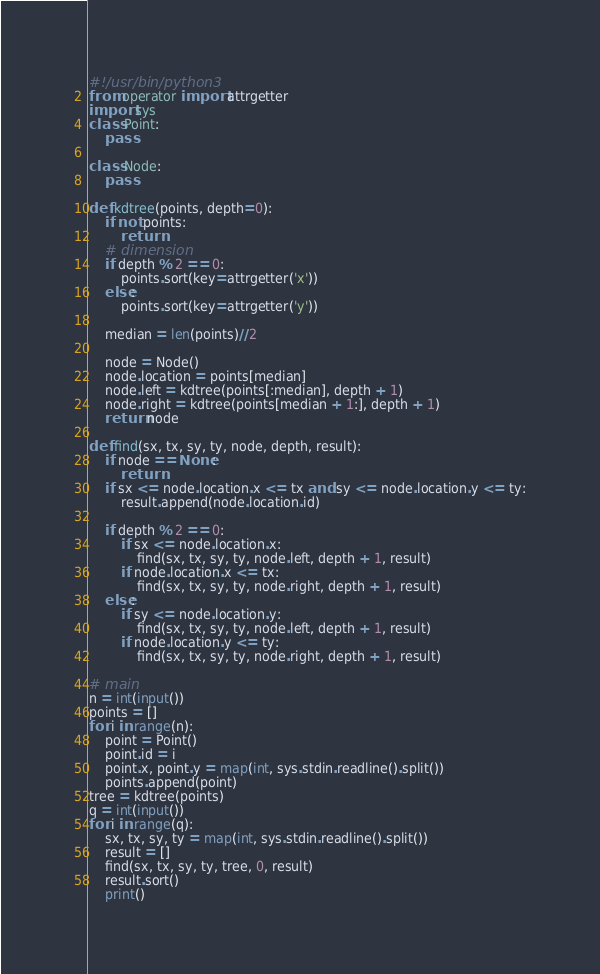<code> <loc_0><loc_0><loc_500><loc_500><_Python_>#!/usr/bin/python3
from operator import attrgetter
import sys
class Point:
    pass

class Node:
    pass

def kdtree(points, depth=0):
    if not points:
        return
    # dimension
    if depth % 2 == 0:
        points.sort(key=attrgetter('x'))
    else:
        points.sort(key=attrgetter('y'))

    median = len(points)//2

    node = Node()
    node.location = points[median]
    node.left = kdtree(points[:median], depth + 1)
    node.right = kdtree(points[median + 1:], depth + 1)
    return node

def find(sx, tx, sy, ty, node, depth, result):
    if node == None:
        return
    if sx <= node.location.x <= tx and sy <= node.location.y <= ty:
        result.append(node.location.id)

    if depth % 2 == 0:
        if sx <= node.location.x:
            find(sx, tx, sy, ty, node.left, depth + 1, result)
        if node.location.x <= tx:
            find(sx, tx, sy, ty, node.right, depth + 1, result)
    else:
        if sy <= node.location.y:
            find(sx, tx, sy, ty, node.left, depth + 1, result)
        if node.location.y <= ty:
            find(sx, tx, sy, ty, node.right, depth + 1, result)

# main
n = int(input())
points = []
for i in range(n):
    point = Point()
    point.id = i
    point.x, point.y = map(int, sys.stdin.readline().split())
    points.append(point)
tree = kdtree(points)
q = int(input())
for i in range(q):
    sx, tx, sy, ty = map(int, sys.stdin.readline().split())
    result = []
    find(sx, tx, sy, ty, tree, 0, result)
    result.sort()
    print()</code> 